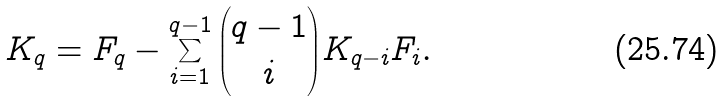<formula> <loc_0><loc_0><loc_500><loc_500>K _ { q } = F _ { q } - \sum _ { i = 1 } ^ { q - 1 } { q - 1 \choose i } K _ { q - i } F _ { i } .</formula> 